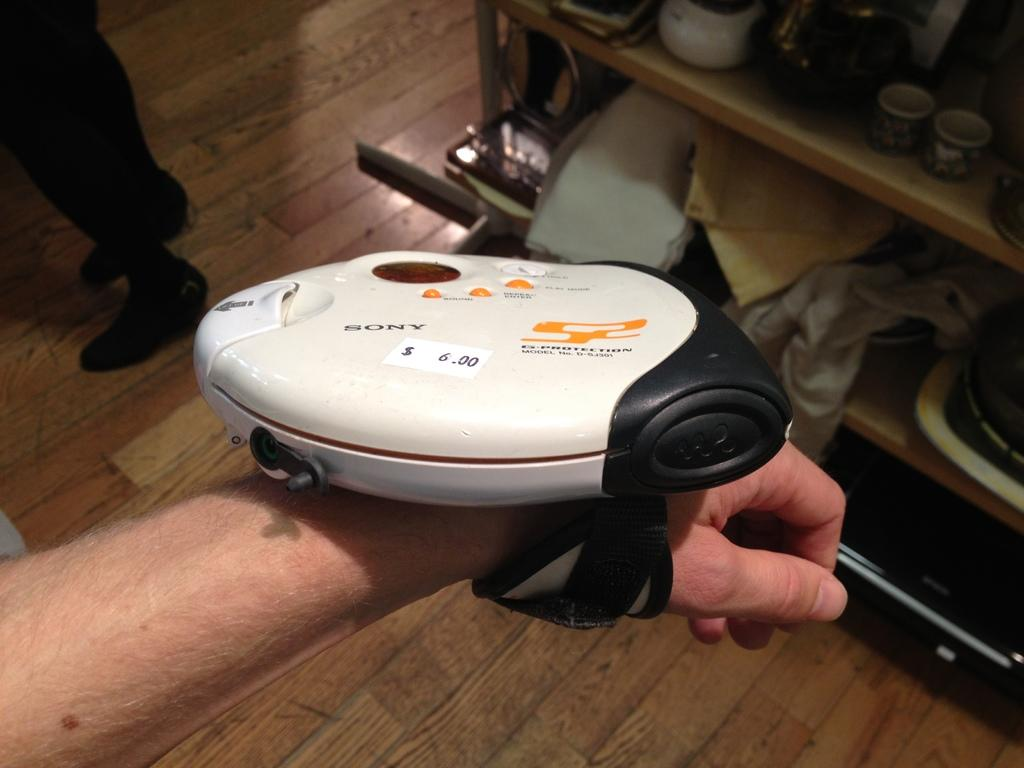What is attached to the human hand in the image? There is a device tied to a human hand in the image. What can be seen on the right side of the image? There is a shelf on the right side of the image. What items are placed on the shelf? Cups and clothes are placed on the shelf. What is visible in the background of the image? There is a floor visible in the background of the image. How many cars are parked on the floor in the image? There are no cars visible in the image; only a shelf with cups and clothes, a floor, and a device tied to a human hand are present. What type of apple is being used as a decoration on the shelf? There is no apple present in the image. 